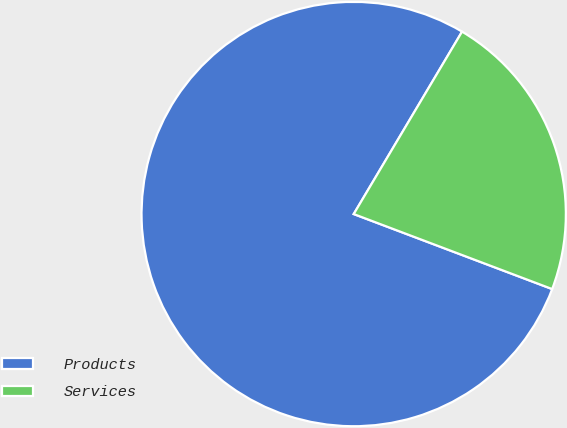Convert chart to OTSL. <chart><loc_0><loc_0><loc_500><loc_500><pie_chart><fcel>Products<fcel>Services<nl><fcel>77.78%<fcel>22.22%<nl></chart> 